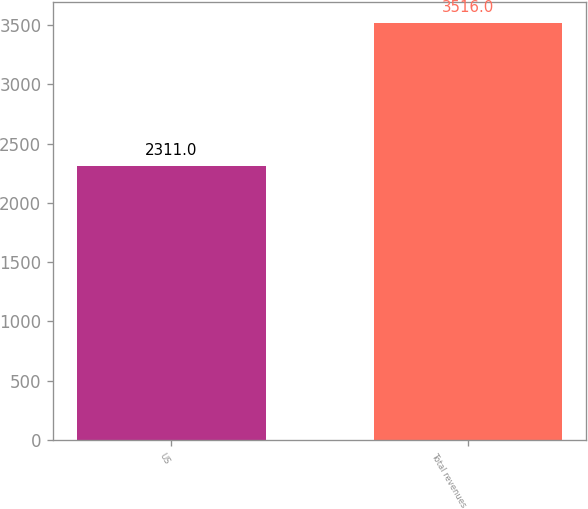Convert chart. <chart><loc_0><loc_0><loc_500><loc_500><bar_chart><fcel>US<fcel>Total revenues<nl><fcel>2311<fcel>3516<nl></chart> 